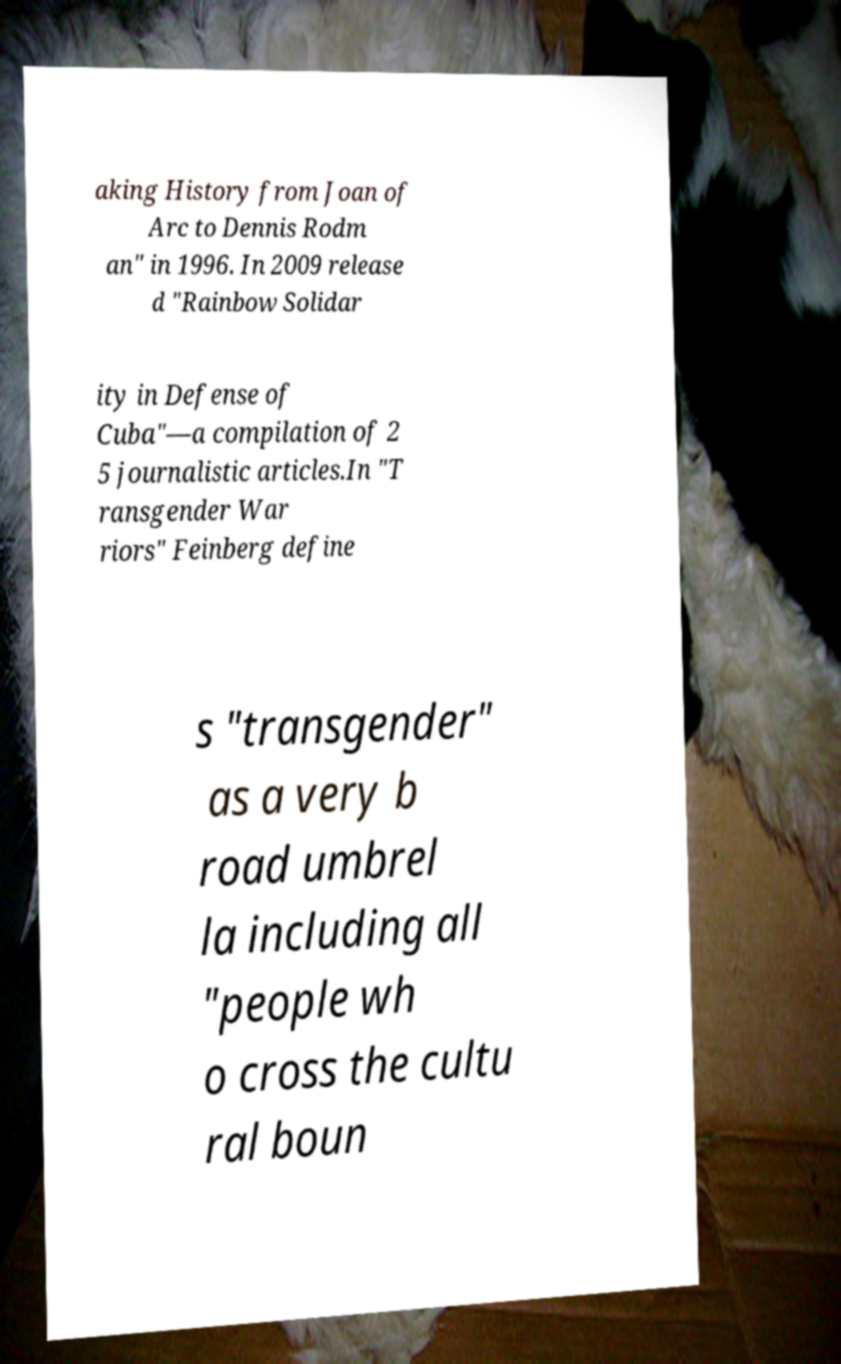I need the written content from this picture converted into text. Can you do that? aking History from Joan of Arc to Dennis Rodm an" in 1996. In 2009 release d "Rainbow Solidar ity in Defense of Cuba"—a compilation of 2 5 journalistic articles.In "T ransgender War riors" Feinberg define s "transgender" as a very b road umbrel la including all "people wh o cross the cultu ral boun 